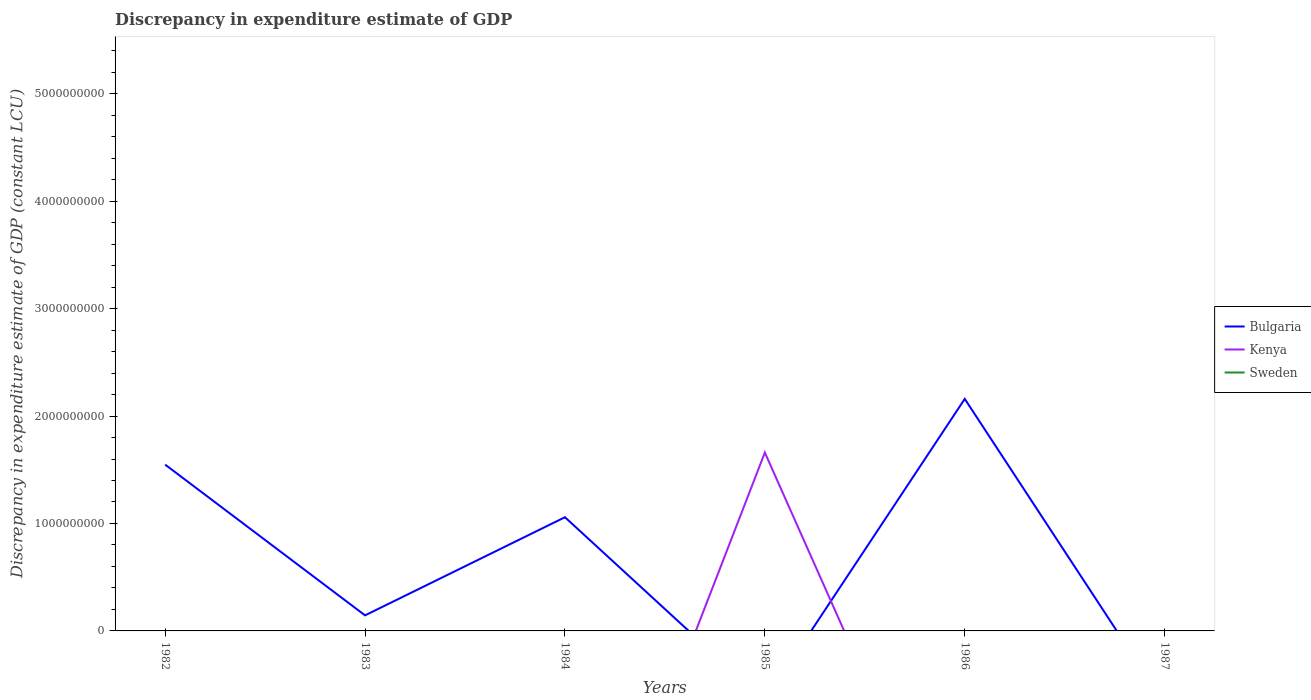Across all years, what is the maximum discrepancy in expenditure estimate of GDP in Bulgaria?
Make the answer very short. 0. What is the difference between the highest and the second highest discrepancy in expenditure estimate of GDP in Kenya?
Keep it short and to the point. 1.66e+09. How many years are there in the graph?
Offer a very short reply. 6. Are the values on the major ticks of Y-axis written in scientific E-notation?
Provide a succinct answer. No. Where does the legend appear in the graph?
Your response must be concise. Center right. How many legend labels are there?
Your answer should be very brief. 3. What is the title of the graph?
Your response must be concise. Discrepancy in expenditure estimate of GDP. Does "Qatar" appear as one of the legend labels in the graph?
Ensure brevity in your answer.  No. What is the label or title of the X-axis?
Make the answer very short. Years. What is the label or title of the Y-axis?
Ensure brevity in your answer.  Discrepancy in expenditure estimate of GDP (constant LCU). What is the Discrepancy in expenditure estimate of GDP (constant LCU) of Bulgaria in 1982?
Your response must be concise. 1.55e+09. What is the Discrepancy in expenditure estimate of GDP (constant LCU) of Sweden in 1982?
Your answer should be compact. 0. What is the Discrepancy in expenditure estimate of GDP (constant LCU) in Bulgaria in 1983?
Provide a succinct answer. 1.45e+08. What is the Discrepancy in expenditure estimate of GDP (constant LCU) of Kenya in 1983?
Provide a succinct answer. 0. What is the Discrepancy in expenditure estimate of GDP (constant LCU) in Bulgaria in 1984?
Give a very brief answer. 1.06e+09. What is the Discrepancy in expenditure estimate of GDP (constant LCU) in Kenya in 1984?
Ensure brevity in your answer.  0. What is the Discrepancy in expenditure estimate of GDP (constant LCU) in Bulgaria in 1985?
Provide a short and direct response. 0. What is the Discrepancy in expenditure estimate of GDP (constant LCU) of Kenya in 1985?
Keep it short and to the point. 1.66e+09. What is the Discrepancy in expenditure estimate of GDP (constant LCU) of Bulgaria in 1986?
Provide a short and direct response. 2.16e+09. What is the Discrepancy in expenditure estimate of GDP (constant LCU) of Kenya in 1986?
Ensure brevity in your answer.  0. What is the Discrepancy in expenditure estimate of GDP (constant LCU) of Sweden in 1986?
Make the answer very short. 0. Across all years, what is the maximum Discrepancy in expenditure estimate of GDP (constant LCU) of Bulgaria?
Provide a succinct answer. 2.16e+09. Across all years, what is the maximum Discrepancy in expenditure estimate of GDP (constant LCU) of Kenya?
Your answer should be compact. 1.66e+09. Across all years, what is the minimum Discrepancy in expenditure estimate of GDP (constant LCU) of Kenya?
Offer a terse response. 0. What is the total Discrepancy in expenditure estimate of GDP (constant LCU) in Bulgaria in the graph?
Provide a succinct answer. 4.91e+09. What is the total Discrepancy in expenditure estimate of GDP (constant LCU) in Kenya in the graph?
Make the answer very short. 1.66e+09. What is the difference between the Discrepancy in expenditure estimate of GDP (constant LCU) in Bulgaria in 1982 and that in 1983?
Give a very brief answer. 1.40e+09. What is the difference between the Discrepancy in expenditure estimate of GDP (constant LCU) of Bulgaria in 1982 and that in 1984?
Make the answer very short. 4.90e+08. What is the difference between the Discrepancy in expenditure estimate of GDP (constant LCU) in Bulgaria in 1982 and that in 1986?
Keep it short and to the point. -6.12e+08. What is the difference between the Discrepancy in expenditure estimate of GDP (constant LCU) in Bulgaria in 1983 and that in 1984?
Make the answer very short. -9.14e+08. What is the difference between the Discrepancy in expenditure estimate of GDP (constant LCU) of Bulgaria in 1983 and that in 1986?
Make the answer very short. -2.01e+09. What is the difference between the Discrepancy in expenditure estimate of GDP (constant LCU) of Bulgaria in 1984 and that in 1986?
Provide a short and direct response. -1.10e+09. What is the difference between the Discrepancy in expenditure estimate of GDP (constant LCU) in Bulgaria in 1982 and the Discrepancy in expenditure estimate of GDP (constant LCU) in Kenya in 1985?
Keep it short and to the point. -1.12e+08. What is the difference between the Discrepancy in expenditure estimate of GDP (constant LCU) in Bulgaria in 1983 and the Discrepancy in expenditure estimate of GDP (constant LCU) in Kenya in 1985?
Offer a very short reply. -1.52e+09. What is the difference between the Discrepancy in expenditure estimate of GDP (constant LCU) of Bulgaria in 1984 and the Discrepancy in expenditure estimate of GDP (constant LCU) of Kenya in 1985?
Keep it short and to the point. -6.02e+08. What is the average Discrepancy in expenditure estimate of GDP (constant LCU) of Bulgaria per year?
Give a very brief answer. 8.18e+08. What is the average Discrepancy in expenditure estimate of GDP (constant LCU) of Kenya per year?
Make the answer very short. 2.77e+08. What is the average Discrepancy in expenditure estimate of GDP (constant LCU) in Sweden per year?
Make the answer very short. 0. What is the ratio of the Discrepancy in expenditure estimate of GDP (constant LCU) in Bulgaria in 1982 to that in 1983?
Offer a terse response. 10.7. What is the ratio of the Discrepancy in expenditure estimate of GDP (constant LCU) in Bulgaria in 1982 to that in 1984?
Ensure brevity in your answer.  1.46. What is the ratio of the Discrepancy in expenditure estimate of GDP (constant LCU) in Bulgaria in 1982 to that in 1986?
Offer a very short reply. 0.72. What is the ratio of the Discrepancy in expenditure estimate of GDP (constant LCU) of Bulgaria in 1983 to that in 1984?
Offer a terse response. 0.14. What is the ratio of the Discrepancy in expenditure estimate of GDP (constant LCU) in Bulgaria in 1983 to that in 1986?
Provide a short and direct response. 0.07. What is the ratio of the Discrepancy in expenditure estimate of GDP (constant LCU) of Bulgaria in 1984 to that in 1986?
Provide a short and direct response. 0.49. What is the difference between the highest and the second highest Discrepancy in expenditure estimate of GDP (constant LCU) in Bulgaria?
Provide a short and direct response. 6.12e+08. What is the difference between the highest and the lowest Discrepancy in expenditure estimate of GDP (constant LCU) in Bulgaria?
Provide a succinct answer. 2.16e+09. What is the difference between the highest and the lowest Discrepancy in expenditure estimate of GDP (constant LCU) in Kenya?
Offer a very short reply. 1.66e+09. 